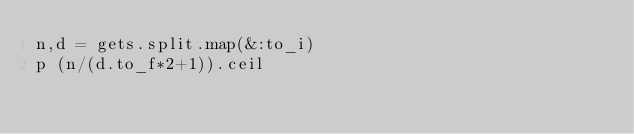<code> <loc_0><loc_0><loc_500><loc_500><_Ruby_>n,d = gets.split.map(&:to_i)
p (n/(d.to_f*2+1)).ceil</code> 